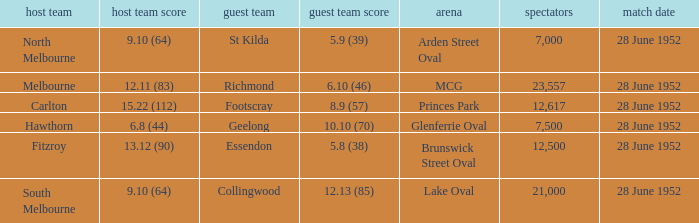Who is the away side when north melbourne is at home and has a score of 9.10 (64)? St Kilda. 